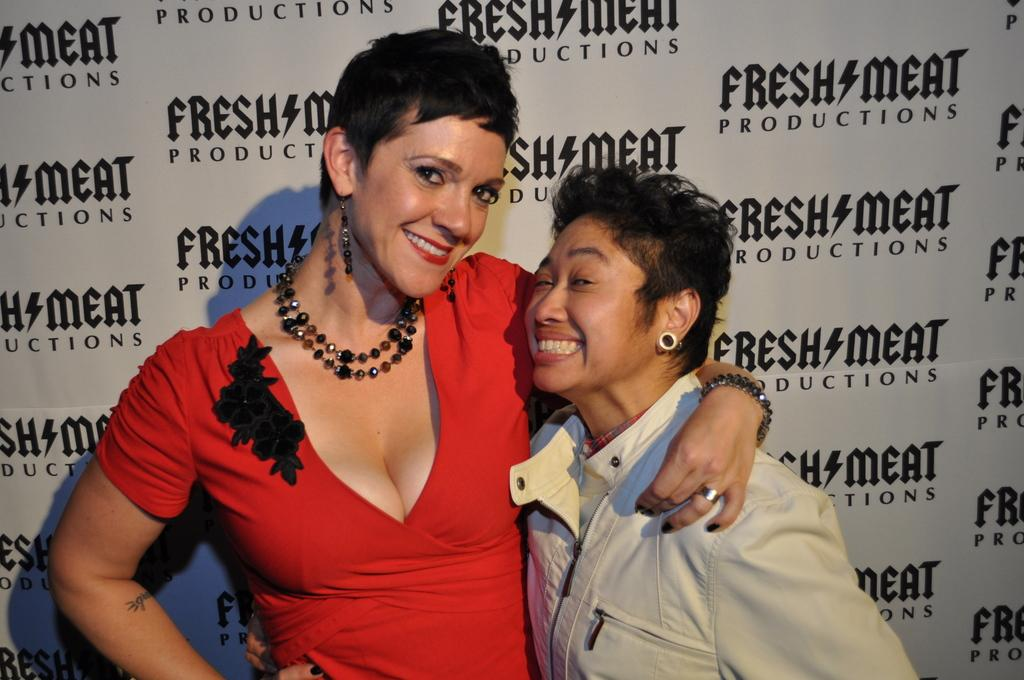How many people are in the image? There are two women in the image. What can be seen in the background of the image? There is a poster in the background of the image. What is written on the poster? There is text written on the poster. Where is the playground located in the image? There is no playground present in the image. What type of pleasure can be seen being enjoyed by the women in the image? The image does not depict any specific pleasure being enjoyed by the women. 